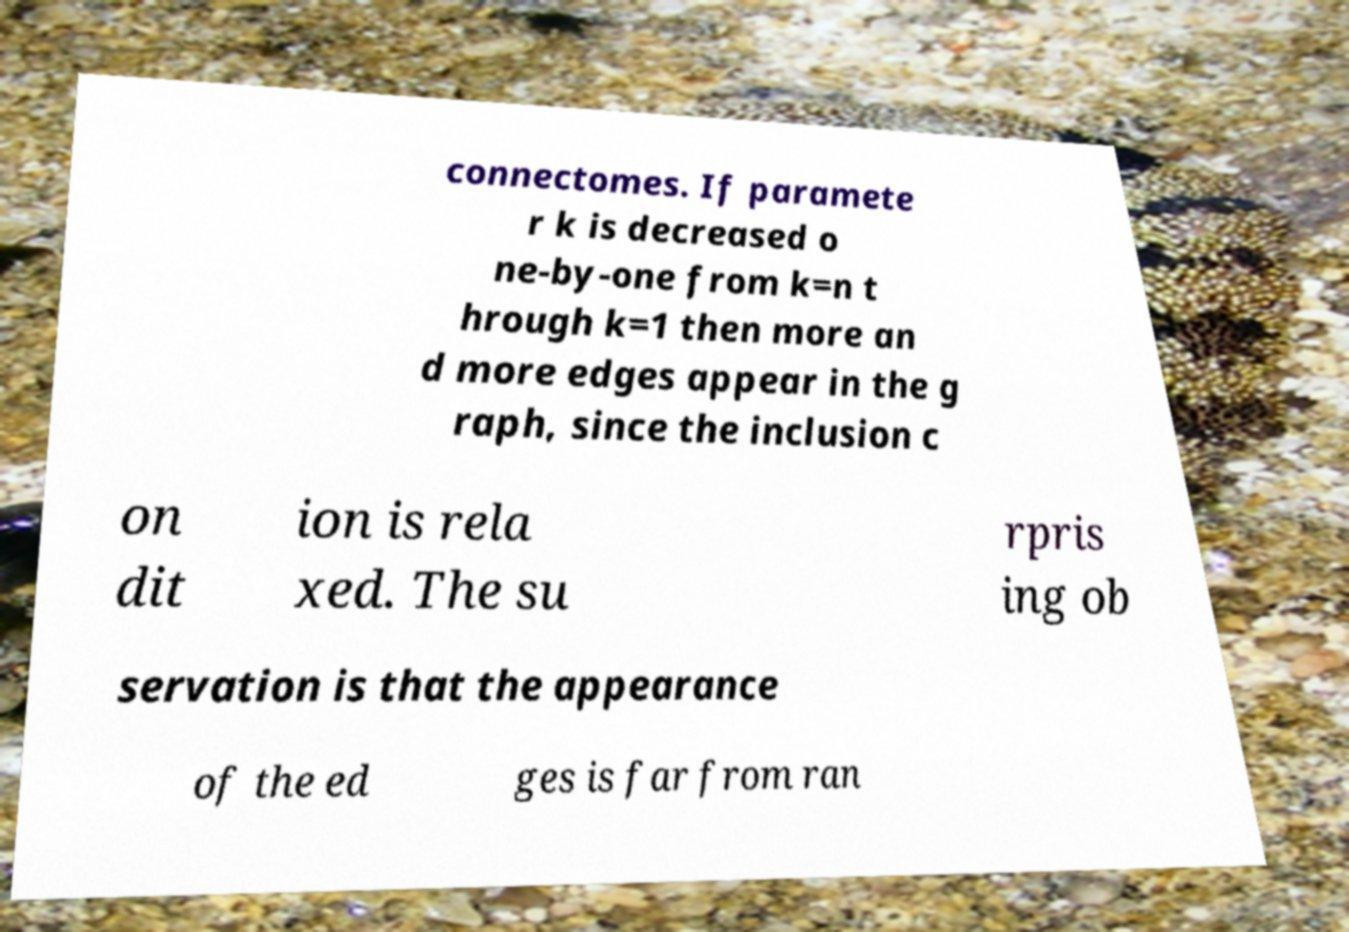Can you accurately transcribe the text from the provided image for me? connectomes. If paramete r k is decreased o ne-by-one from k=n t hrough k=1 then more an d more edges appear in the g raph, since the inclusion c on dit ion is rela xed. The su rpris ing ob servation is that the appearance of the ed ges is far from ran 